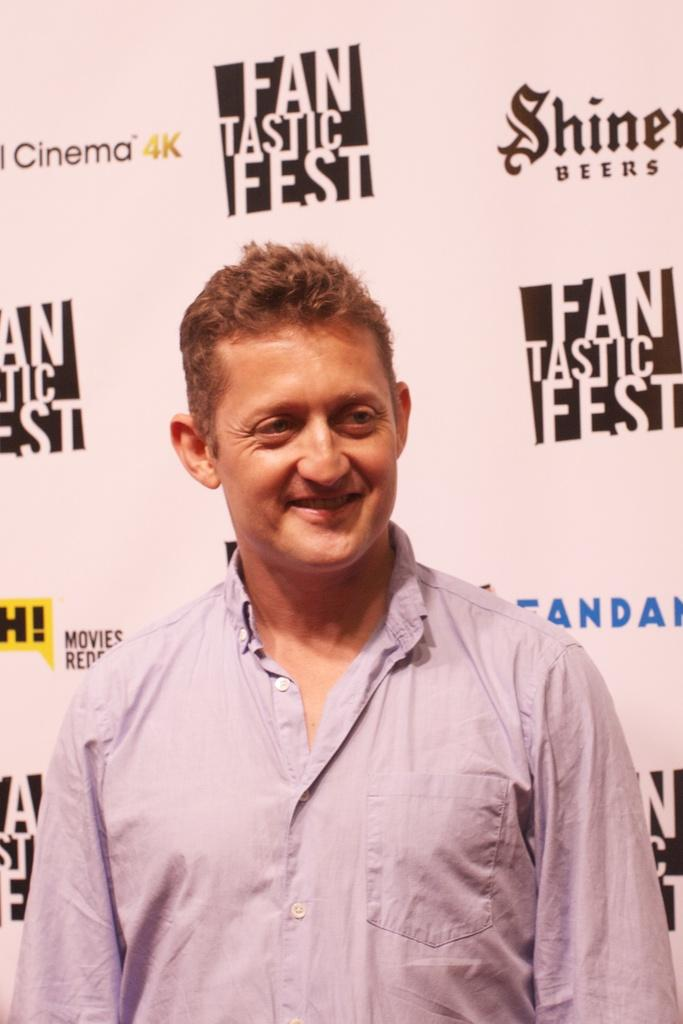<image>
Relay a brief, clear account of the picture shown. a man standing in front of a fantastic fest sign 